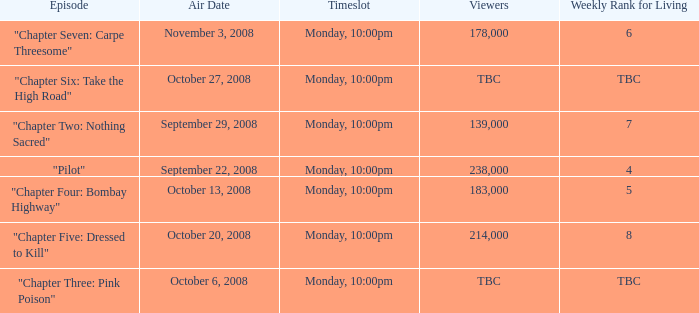Parse the full table. {'header': ['Episode', 'Air Date', 'Timeslot', 'Viewers', 'Weekly Rank for Living'], 'rows': [['"Chapter Seven: Carpe Threesome"', 'November 3, 2008', 'Monday, 10:00pm', '178,000', '6'], ['"Chapter Six: Take the High Road"', 'October 27, 2008', 'Monday, 10:00pm', 'TBC', 'TBC'], ['"Chapter Two: Nothing Sacred"', 'September 29, 2008', 'Monday, 10:00pm', '139,000', '7'], ['"Pilot"', 'September 22, 2008', 'Monday, 10:00pm', '238,000', '4'], ['"Chapter Four: Bombay Highway"', 'October 13, 2008', 'Monday, 10:00pm', '183,000', '5'], ['"Chapter Five: Dressed to Kill"', 'October 20, 2008', 'Monday, 10:00pm', '214,000', '8'], ['"Chapter Three: Pink Poison"', 'October 6, 2008', 'Monday, 10:00pm', 'TBC', 'TBC']]} What is the episode with the 183,000 viewers? "Chapter Four: Bombay Highway". 